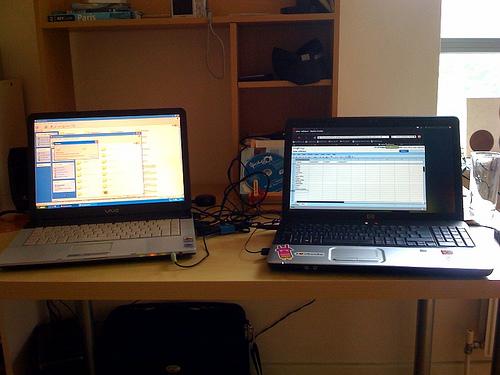What are the computers on?
Keep it brief. Desk. What brand of computer is on the left?
Write a very short answer. Vaio. Are both monitors showing the same screen?
Quick response, please. No. How many laptops in the photo?
Concise answer only. 2. Do many laptops do you see?
Quick response, please. 2. Is there a lamp on the desk?
Keep it brief. No. What is this place?
Keep it brief. Office. Are both screens the same size?
Keep it brief. Yes. How many monitors are there?
Concise answer only. 2. How many monitors have a black display with white writing?
Give a very brief answer. 1. Is there a sticker on either laptop?
Concise answer only. Yes. Is the desk made of metal?
Write a very short answer. No. 